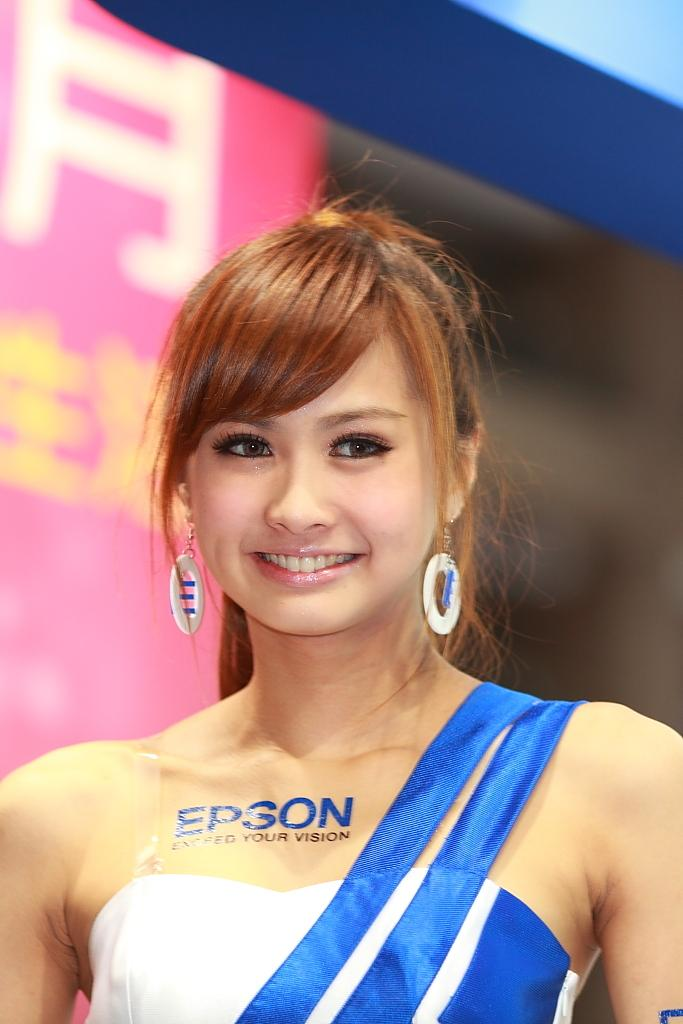<image>
Share a concise interpretation of the image provided. a lady with the word Epson on her body 